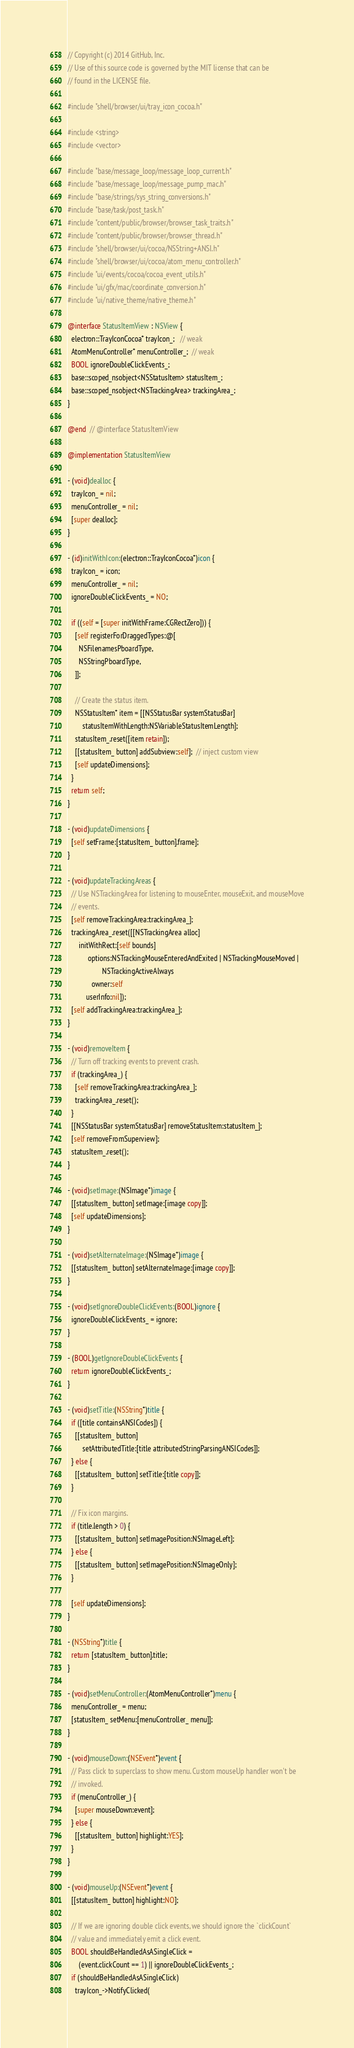<code> <loc_0><loc_0><loc_500><loc_500><_ObjectiveC_>// Copyright (c) 2014 GitHub, Inc.
// Use of this source code is governed by the MIT license that can be
// found in the LICENSE file.

#include "shell/browser/ui/tray_icon_cocoa.h"

#include <string>
#include <vector>

#include "base/message_loop/message_loop_current.h"
#include "base/message_loop/message_pump_mac.h"
#include "base/strings/sys_string_conversions.h"
#include "base/task/post_task.h"
#include "content/public/browser/browser_task_traits.h"
#include "content/public/browser/browser_thread.h"
#include "shell/browser/ui/cocoa/NSString+ANSI.h"
#include "shell/browser/ui/cocoa/atom_menu_controller.h"
#include "ui/events/cocoa/cocoa_event_utils.h"
#include "ui/gfx/mac/coordinate_conversion.h"
#include "ui/native_theme/native_theme.h"

@interface StatusItemView : NSView {
  electron::TrayIconCocoa* trayIcon_;   // weak
  AtomMenuController* menuController_;  // weak
  BOOL ignoreDoubleClickEvents_;
  base::scoped_nsobject<NSStatusItem> statusItem_;
  base::scoped_nsobject<NSTrackingArea> trackingArea_;
}

@end  // @interface StatusItemView

@implementation StatusItemView

- (void)dealloc {
  trayIcon_ = nil;
  menuController_ = nil;
  [super dealloc];
}

- (id)initWithIcon:(electron::TrayIconCocoa*)icon {
  trayIcon_ = icon;
  menuController_ = nil;
  ignoreDoubleClickEvents_ = NO;

  if ((self = [super initWithFrame:CGRectZero])) {
    [self registerForDraggedTypes:@[
      NSFilenamesPboardType,
      NSStringPboardType,
    ]];

    // Create the status item.
    NSStatusItem* item = [[NSStatusBar systemStatusBar]
        statusItemWithLength:NSVariableStatusItemLength];
    statusItem_.reset([item retain]);
    [[statusItem_ button] addSubview:self];  // inject custom view
    [self updateDimensions];
  }
  return self;
}

- (void)updateDimensions {
  [self setFrame:[statusItem_ button].frame];
}

- (void)updateTrackingAreas {
  // Use NSTrackingArea for listening to mouseEnter, mouseExit, and mouseMove
  // events.
  [self removeTrackingArea:trackingArea_];
  trackingArea_.reset([[NSTrackingArea alloc]
      initWithRect:[self bounds]
           options:NSTrackingMouseEnteredAndExited | NSTrackingMouseMoved |
                   NSTrackingActiveAlways
             owner:self
          userInfo:nil]);
  [self addTrackingArea:trackingArea_];
}

- (void)removeItem {
  // Turn off tracking events to prevent crash.
  if (trackingArea_) {
    [self removeTrackingArea:trackingArea_];
    trackingArea_.reset();
  }
  [[NSStatusBar systemStatusBar] removeStatusItem:statusItem_];
  [self removeFromSuperview];
  statusItem_.reset();
}

- (void)setImage:(NSImage*)image {
  [[statusItem_ button] setImage:[image copy]];
  [self updateDimensions];
}

- (void)setAlternateImage:(NSImage*)image {
  [[statusItem_ button] setAlternateImage:[image copy]];
}

- (void)setIgnoreDoubleClickEvents:(BOOL)ignore {
  ignoreDoubleClickEvents_ = ignore;
}

- (BOOL)getIgnoreDoubleClickEvents {
  return ignoreDoubleClickEvents_;
}

- (void)setTitle:(NSString*)title {
  if ([title containsANSICodes]) {
    [[statusItem_ button]
        setAttributedTitle:[title attributedStringParsingANSICodes]];
  } else {
    [[statusItem_ button] setTitle:[title copy]];
  }

  // Fix icon margins.
  if (title.length > 0) {
    [[statusItem_ button] setImagePosition:NSImageLeft];
  } else {
    [[statusItem_ button] setImagePosition:NSImageOnly];
  }

  [self updateDimensions];
}

- (NSString*)title {
  return [statusItem_ button].title;
}

- (void)setMenuController:(AtomMenuController*)menu {
  menuController_ = menu;
  [statusItem_ setMenu:[menuController_ menu]];
}

- (void)mouseDown:(NSEvent*)event {
  // Pass click to superclass to show menu. Custom mouseUp handler won't be
  // invoked.
  if (menuController_) {
    [super mouseDown:event];
  } else {
    [[statusItem_ button] highlight:YES];
  }
}

- (void)mouseUp:(NSEvent*)event {
  [[statusItem_ button] highlight:NO];

  // If we are ignoring double click events, we should ignore the `clickCount`
  // value and immediately emit a click event.
  BOOL shouldBeHandledAsASingleClick =
      (event.clickCount == 1) || ignoreDoubleClickEvents_;
  if (shouldBeHandledAsASingleClick)
    trayIcon_->NotifyClicked(</code> 